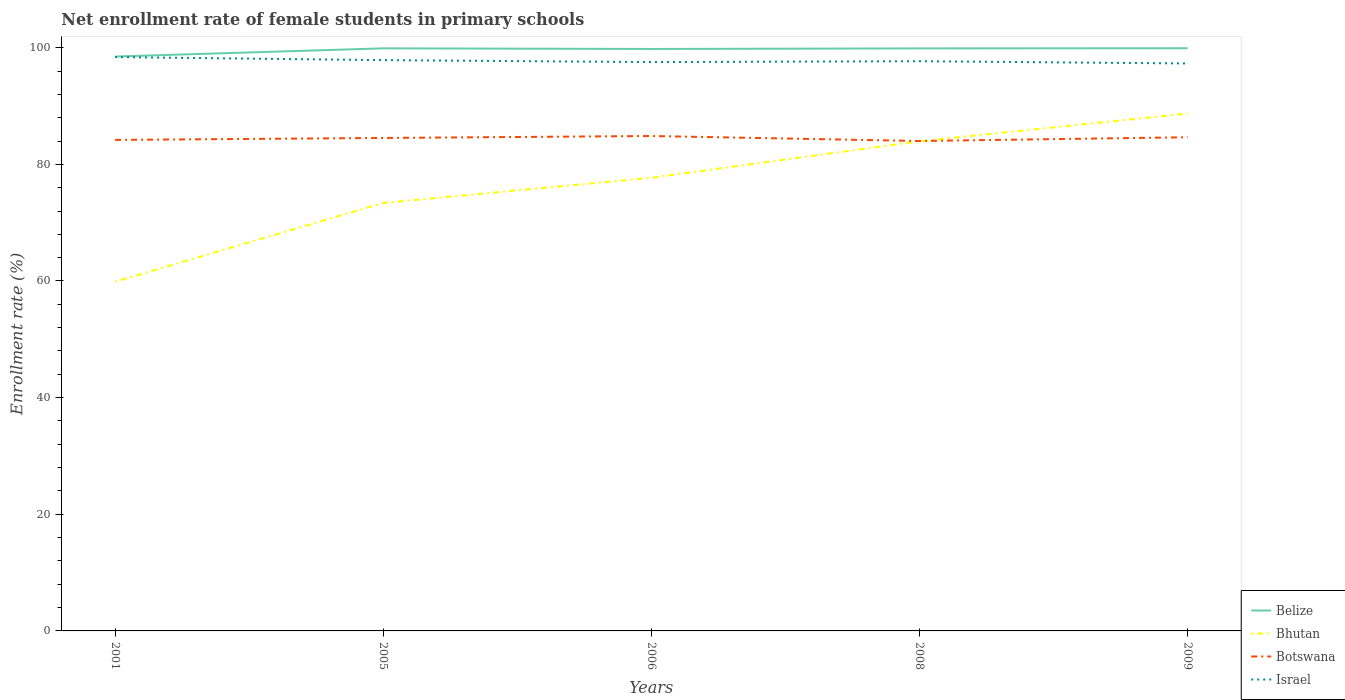How many different coloured lines are there?
Provide a short and direct response. 4. Is the number of lines equal to the number of legend labels?
Offer a terse response. Yes. Across all years, what is the maximum net enrollment rate of female students in primary schools in Israel?
Your answer should be very brief. 97.3. What is the total net enrollment rate of female students in primary schools in Bhutan in the graph?
Provide a succinct answer. -10.58. What is the difference between the highest and the second highest net enrollment rate of female students in primary schools in Botswana?
Provide a short and direct response. 0.86. What is the difference between the highest and the lowest net enrollment rate of female students in primary schools in Israel?
Provide a succinct answer. 2. Is the net enrollment rate of female students in primary schools in Israel strictly greater than the net enrollment rate of female students in primary schools in Botswana over the years?
Provide a short and direct response. No. Are the values on the major ticks of Y-axis written in scientific E-notation?
Your answer should be very brief. No. Does the graph contain grids?
Offer a terse response. No. Where does the legend appear in the graph?
Offer a very short reply. Bottom right. How many legend labels are there?
Your response must be concise. 4. How are the legend labels stacked?
Give a very brief answer. Vertical. What is the title of the graph?
Ensure brevity in your answer.  Net enrollment rate of female students in primary schools. Does "Kazakhstan" appear as one of the legend labels in the graph?
Provide a succinct answer. No. What is the label or title of the X-axis?
Your response must be concise. Years. What is the label or title of the Y-axis?
Your answer should be compact. Enrollment rate (%). What is the Enrollment rate (%) of Belize in 2001?
Your answer should be very brief. 98.49. What is the Enrollment rate (%) in Bhutan in 2001?
Ensure brevity in your answer.  59.88. What is the Enrollment rate (%) in Botswana in 2001?
Provide a succinct answer. 84.19. What is the Enrollment rate (%) in Israel in 2001?
Ensure brevity in your answer.  98.39. What is the Enrollment rate (%) in Belize in 2005?
Keep it short and to the point. 99.89. What is the Enrollment rate (%) in Bhutan in 2005?
Offer a terse response. 73.38. What is the Enrollment rate (%) of Botswana in 2005?
Ensure brevity in your answer.  84.52. What is the Enrollment rate (%) in Israel in 2005?
Ensure brevity in your answer.  97.87. What is the Enrollment rate (%) of Belize in 2006?
Offer a terse response. 99.78. What is the Enrollment rate (%) in Bhutan in 2006?
Your answer should be very brief. 77.7. What is the Enrollment rate (%) in Botswana in 2006?
Make the answer very short. 84.86. What is the Enrollment rate (%) of Israel in 2006?
Ensure brevity in your answer.  97.53. What is the Enrollment rate (%) in Belize in 2008?
Offer a very short reply. 99.88. What is the Enrollment rate (%) of Bhutan in 2008?
Keep it short and to the point. 83.95. What is the Enrollment rate (%) of Botswana in 2008?
Offer a very short reply. 84. What is the Enrollment rate (%) in Israel in 2008?
Your answer should be compact. 97.68. What is the Enrollment rate (%) in Belize in 2009?
Provide a succinct answer. 99.91. What is the Enrollment rate (%) of Bhutan in 2009?
Ensure brevity in your answer.  88.72. What is the Enrollment rate (%) of Botswana in 2009?
Your answer should be compact. 84.65. What is the Enrollment rate (%) in Israel in 2009?
Offer a terse response. 97.3. Across all years, what is the maximum Enrollment rate (%) in Belize?
Offer a very short reply. 99.91. Across all years, what is the maximum Enrollment rate (%) of Bhutan?
Ensure brevity in your answer.  88.72. Across all years, what is the maximum Enrollment rate (%) in Botswana?
Give a very brief answer. 84.86. Across all years, what is the maximum Enrollment rate (%) of Israel?
Your answer should be compact. 98.39. Across all years, what is the minimum Enrollment rate (%) of Belize?
Offer a very short reply. 98.49. Across all years, what is the minimum Enrollment rate (%) in Bhutan?
Your answer should be very brief. 59.88. Across all years, what is the minimum Enrollment rate (%) in Botswana?
Keep it short and to the point. 84. Across all years, what is the minimum Enrollment rate (%) of Israel?
Offer a terse response. 97.3. What is the total Enrollment rate (%) in Belize in the graph?
Ensure brevity in your answer.  497.95. What is the total Enrollment rate (%) in Bhutan in the graph?
Give a very brief answer. 383.63. What is the total Enrollment rate (%) of Botswana in the graph?
Offer a very short reply. 422.23. What is the total Enrollment rate (%) of Israel in the graph?
Your answer should be compact. 488.78. What is the difference between the Enrollment rate (%) in Belize in 2001 and that in 2005?
Provide a succinct answer. -1.4. What is the difference between the Enrollment rate (%) of Bhutan in 2001 and that in 2005?
Your answer should be compact. -13.5. What is the difference between the Enrollment rate (%) of Botswana in 2001 and that in 2005?
Offer a very short reply. -0.33. What is the difference between the Enrollment rate (%) of Israel in 2001 and that in 2005?
Provide a succinct answer. 0.52. What is the difference between the Enrollment rate (%) in Belize in 2001 and that in 2006?
Provide a short and direct response. -1.3. What is the difference between the Enrollment rate (%) in Bhutan in 2001 and that in 2006?
Make the answer very short. -17.82. What is the difference between the Enrollment rate (%) in Botswana in 2001 and that in 2006?
Provide a short and direct response. -0.67. What is the difference between the Enrollment rate (%) in Israel in 2001 and that in 2006?
Ensure brevity in your answer.  0.86. What is the difference between the Enrollment rate (%) of Belize in 2001 and that in 2008?
Your answer should be very brief. -1.4. What is the difference between the Enrollment rate (%) in Bhutan in 2001 and that in 2008?
Your answer should be very brief. -24.08. What is the difference between the Enrollment rate (%) of Botswana in 2001 and that in 2008?
Make the answer very short. 0.19. What is the difference between the Enrollment rate (%) of Israel in 2001 and that in 2008?
Your response must be concise. 0.7. What is the difference between the Enrollment rate (%) of Belize in 2001 and that in 2009?
Offer a terse response. -1.42. What is the difference between the Enrollment rate (%) in Bhutan in 2001 and that in 2009?
Your answer should be compact. -28.84. What is the difference between the Enrollment rate (%) of Botswana in 2001 and that in 2009?
Keep it short and to the point. -0.45. What is the difference between the Enrollment rate (%) in Israel in 2001 and that in 2009?
Ensure brevity in your answer.  1.09. What is the difference between the Enrollment rate (%) of Belize in 2005 and that in 2006?
Your answer should be compact. 0.11. What is the difference between the Enrollment rate (%) in Bhutan in 2005 and that in 2006?
Make the answer very short. -4.32. What is the difference between the Enrollment rate (%) of Botswana in 2005 and that in 2006?
Make the answer very short. -0.33. What is the difference between the Enrollment rate (%) of Israel in 2005 and that in 2006?
Provide a succinct answer. 0.34. What is the difference between the Enrollment rate (%) of Belize in 2005 and that in 2008?
Your answer should be compact. 0.01. What is the difference between the Enrollment rate (%) in Bhutan in 2005 and that in 2008?
Keep it short and to the point. -10.58. What is the difference between the Enrollment rate (%) of Botswana in 2005 and that in 2008?
Your response must be concise. 0.52. What is the difference between the Enrollment rate (%) in Israel in 2005 and that in 2008?
Give a very brief answer. 0.19. What is the difference between the Enrollment rate (%) in Belize in 2005 and that in 2009?
Your answer should be very brief. -0.02. What is the difference between the Enrollment rate (%) of Bhutan in 2005 and that in 2009?
Give a very brief answer. -15.34. What is the difference between the Enrollment rate (%) in Botswana in 2005 and that in 2009?
Make the answer very short. -0.12. What is the difference between the Enrollment rate (%) in Israel in 2005 and that in 2009?
Offer a very short reply. 0.57. What is the difference between the Enrollment rate (%) in Belize in 2006 and that in 2008?
Your answer should be very brief. -0.1. What is the difference between the Enrollment rate (%) of Bhutan in 2006 and that in 2008?
Your answer should be compact. -6.25. What is the difference between the Enrollment rate (%) in Botswana in 2006 and that in 2008?
Your answer should be compact. 0.86. What is the difference between the Enrollment rate (%) in Israel in 2006 and that in 2008?
Your answer should be very brief. -0.15. What is the difference between the Enrollment rate (%) in Belize in 2006 and that in 2009?
Keep it short and to the point. -0.12. What is the difference between the Enrollment rate (%) in Bhutan in 2006 and that in 2009?
Offer a terse response. -11.02. What is the difference between the Enrollment rate (%) in Botswana in 2006 and that in 2009?
Make the answer very short. 0.21. What is the difference between the Enrollment rate (%) in Israel in 2006 and that in 2009?
Your answer should be very brief. 0.23. What is the difference between the Enrollment rate (%) in Belize in 2008 and that in 2009?
Offer a terse response. -0.02. What is the difference between the Enrollment rate (%) of Bhutan in 2008 and that in 2009?
Provide a short and direct response. -4.76. What is the difference between the Enrollment rate (%) of Botswana in 2008 and that in 2009?
Offer a very short reply. -0.64. What is the difference between the Enrollment rate (%) of Israel in 2008 and that in 2009?
Your response must be concise. 0.38. What is the difference between the Enrollment rate (%) in Belize in 2001 and the Enrollment rate (%) in Bhutan in 2005?
Your answer should be very brief. 25.11. What is the difference between the Enrollment rate (%) of Belize in 2001 and the Enrollment rate (%) of Botswana in 2005?
Give a very brief answer. 13.96. What is the difference between the Enrollment rate (%) of Belize in 2001 and the Enrollment rate (%) of Israel in 2005?
Your response must be concise. 0.62. What is the difference between the Enrollment rate (%) in Bhutan in 2001 and the Enrollment rate (%) in Botswana in 2005?
Keep it short and to the point. -24.65. What is the difference between the Enrollment rate (%) in Bhutan in 2001 and the Enrollment rate (%) in Israel in 2005?
Offer a terse response. -37.99. What is the difference between the Enrollment rate (%) of Botswana in 2001 and the Enrollment rate (%) of Israel in 2005?
Offer a very short reply. -13.68. What is the difference between the Enrollment rate (%) of Belize in 2001 and the Enrollment rate (%) of Bhutan in 2006?
Keep it short and to the point. 20.78. What is the difference between the Enrollment rate (%) of Belize in 2001 and the Enrollment rate (%) of Botswana in 2006?
Provide a short and direct response. 13.63. What is the difference between the Enrollment rate (%) of Belize in 2001 and the Enrollment rate (%) of Israel in 2006?
Make the answer very short. 0.95. What is the difference between the Enrollment rate (%) in Bhutan in 2001 and the Enrollment rate (%) in Botswana in 2006?
Provide a short and direct response. -24.98. What is the difference between the Enrollment rate (%) of Bhutan in 2001 and the Enrollment rate (%) of Israel in 2006?
Ensure brevity in your answer.  -37.65. What is the difference between the Enrollment rate (%) in Botswana in 2001 and the Enrollment rate (%) in Israel in 2006?
Your answer should be compact. -13.34. What is the difference between the Enrollment rate (%) in Belize in 2001 and the Enrollment rate (%) in Bhutan in 2008?
Your answer should be compact. 14.53. What is the difference between the Enrollment rate (%) in Belize in 2001 and the Enrollment rate (%) in Botswana in 2008?
Offer a very short reply. 14.48. What is the difference between the Enrollment rate (%) in Belize in 2001 and the Enrollment rate (%) in Israel in 2008?
Ensure brevity in your answer.  0.8. What is the difference between the Enrollment rate (%) of Bhutan in 2001 and the Enrollment rate (%) of Botswana in 2008?
Ensure brevity in your answer.  -24.13. What is the difference between the Enrollment rate (%) of Bhutan in 2001 and the Enrollment rate (%) of Israel in 2008?
Keep it short and to the point. -37.81. What is the difference between the Enrollment rate (%) in Botswana in 2001 and the Enrollment rate (%) in Israel in 2008?
Give a very brief answer. -13.49. What is the difference between the Enrollment rate (%) in Belize in 2001 and the Enrollment rate (%) in Bhutan in 2009?
Your response must be concise. 9.77. What is the difference between the Enrollment rate (%) in Belize in 2001 and the Enrollment rate (%) in Botswana in 2009?
Your answer should be compact. 13.84. What is the difference between the Enrollment rate (%) in Belize in 2001 and the Enrollment rate (%) in Israel in 2009?
Give a very brief answer. 1.19. What is the difference between the Enrollment rate (%) of Bhutan in 2001 and the Enrollment rate (%) of Botswana in 2009?
Keep it short and to the point. -24.77. What is the difference between the Enrollment rate (%) in Bhutan in 2001 and the Enrollment rate (%) in Israel in 2009?
Give a very brief answer. -37.42. What is the difference between the Enrollment rate (%) in Botswana in 2001 and the Enrollment rate (%) in Israel in 2009?
Give a very brief answer. -13.11. What is the difference between the Enrollment rate (%) in Belize in 2005 and the Enrollment rate (%) in Bhutan in 2006?
Offer a very short reply. 22.19. What is the difference between the Enrollment rate (%) in Belize in 2005 and the Enrollment rate (%) in Botswana in 2006?
Provide a succinct answer. 15.03. What is the difference between the Enrollment rate (%) in Belize in 2005 and the Enrollment rate (%) in Israel in 2006?
Keep it short and to the point. 2.36. What is the difference between the Enrollment rate (%) in Bhutan in 2005 and the Enrollment rate (%) in Botswana in 2006?
Give a very brief answer. -11.48. What is the difference between the Enrollment rate (%) of Bhutan in 2005 and the Enrollment rate (%) of Israel in 2006?
Keep it short and to the point. -24.15. What is the difference between the Enrollment rate (%) in Botswana in 2005 and the Enrollment rate (%) in Israel in 2006?
Make the answer very short. -13.01. What is the difference between the Enrollment rate (%) of Belize in 2005 and the Enrollment rate (%) of Bhutan in 2008?
Keep it short and to the point. 15.94. What is the difference between the Enrollment rate (%) in Belize in 2005 and the Enrollment rate (%) in Botswana in 2008?
Your response must be concise. 15.89. What is the difference between the Enrollment rate (%) in Belize in 2005 and the Enrollment rate (%) in Israel in 2008?
Your response must be concise. 2.21. What is the difference between the Enrollment rate (%) in Bhutan in 2005 and the Enrollment rate (%) in Botswana in 2008?
Offer a very short reply. -10.63. What is the difference between the Enrollment rate (%) of Bhutan in 2005 and the Enrollment rate (%) of Israel in 2008?
Make the answer very short. -24.31. What is the difference between the Enrollment rate (%) of Botswana in 2005 and the Enrollment rate (%) of Israel in 2008?
Offer a very short reply. -13.16. What is the difference between the Enrollment rate (%) in Belize in 2005 and the Enrollment rate (%) in Bhutan in 2009?
Your response must be concise. 11.17. What is the difference between the Enrollment rate (%) in Belize in 2005 and the Enrollment rate (%) in Botswana in 2009?
Provide a short and direct response. 15.24. What is the difference between the Enrollment rate (%) in Belize in 2005 and the Enrollment rate (%) in Israel in 2009?
Provide a succinct answer. 2.59. What is the difference between the Enrollment rate (%) in Bhutan in 2005 and the Enrollment rate (%) in Botswana in 2009?
Offer a very short reply. -11.27. What is the difference between the Enrollment rate (%) of Bhutan in 2005 and the Enrollment rate (%) of Israel in 2009?
Make the answer very short. -23.92. What is the difference between the Enrollment rate (%) in Botswana in 2005 and the Enrollment rate (%) in Israel in 2009?
Your response must be concise. -12.78. What is the difference between the Enrollment rate (%) in Belize in 2006 and the Enrollment rate (%) in Bhutan in 2008?
Your response must be concise. 15.83. What is the difference between the Enrollment rate (%) of Belize in 2006 and the Enrollment rate (%) of Botswana in 2008?
Ensure brevity in your answer.  15.78. What is the difference between the Enrollment rate (%) in Belize in 2006 and the Enrollment rate (%) in Israel in 2008?
Your answer should be very brief. 2.1. What is the difference between the Enrollment rate (%) in Bhutan in 2006 and the Enrollment rate (%) in Botswana in 2008?
Offer a very short reply. -6.3. What is the difference between the Enrollment rate (%) in Bhutan in 2006 and the Enrollment rate (%) in Israel in 2008?
Make the answer very short. -19.98. What is the difference between the Enrollment rate (%) in Botswana in 2006 and the Enrollment rate (%) in Israel in 2008?
Provide a short and direct response. -12.83. What is the difference between the Enrollment rate (%) in Belize in 2006 and the Enrollment rate (%) in Bhutan in 2009?
Your response must be concise. 11.06. What is the difference between the Enrollment rate (%) in Belize in 2006 and the Enrollment rate (%) in Botswana in 2009?
Provide a succinct answer. 15.14. What is the difference between the Enrollment rate (%) of Belize in 2006 and the Enrollment rate (%) of Israel in 2009?
Provide a short and direct response. 2.48. What is the difference between the Enrollment rate (%) in Bhutan in 2006 and the Enrollment rate (%) in Botswana in 2009?
Provide a succinct answer. -6.95. What is the difference between the Enrollment rate (%) of Bhutan in 2006 and the Enrollment rate (%) of Israel in 2009?
Your response must be concise. -19.6. What is the difference between the Enrollment rate (%) of Botswana in 2006 and the Enrollment rate (%) of Israel in 2009?
Keep it short and to the point. -12.44. What is the difference between the Enrollment rate (%) of Belize in 2008 and the Enrollment rate (%) of Bhutan in 2009?
Offer a very short reply. 11.16. What is the difference between the Enrollment rate (%) of Belize in 2008 and the Enrollment rate (%) of Botswana in 2009?
Your answer should be compact. 15.24. What is the difference between the Enrollment rate (%) in Belize in 2008 and the Enrollment rate (%) in Israel in 2009?
Provide a short and direct response. 2.58. What is the difference between the Enrollment rate (%) in Bhutan in 2008 and the Enrollment rate (%) in Botswana in 2009?
Make the answer very short. -0.69. What is the difference between the Enrollment rate (%) in Bhutan in 2008 and the Enrollment rate (%) in Israel in 2009?
Keep it short and to the point. -13.35. What is the difference between the Enrollment rate (%) in Botswana in 2008 and the Enrollment rate (%) in Israel in 2009?
Provide a succinct answer. -13.3. What is the average Enrollment rate (%) in Belize per year?
Your answer should be very brief. 99.59. What is the average Enrollment rate (%) in Bhutan per year?
Keep it short and to the point. 76.73. What is the average Enrollment rate (%) in Botswana per year?
Offer a terse response. 84.44. What is the average Enrollment rate (%) in Israel per year?
Provide a short and direct response. 97.76. In the year 2001, what is the difference between the Enrollment rate (%) in Belize and Enrollment rate (%) in Bhutan?
Keep it short and to the point. 38.61. In the year 2001, what is the difference between the Enrollment rate (%) in Belize and Enrollment rate (%) in Botswana?
Give a very brief answer. 14.29. In the year 2001, what is the difference between the Enrollment rate (%) of Belize and Enrollment rate (%) of Israel?
Make the answer very short. 0.1. In the year 2001, what is the difference between the Enrollment rate (%) in Bhutan and Enrollment rate (%) in Botswana?
Ensure brevity in your answer.  -24.32. In the year 2001, what is the difference between the Enrollment rate (%) of Bhutan and Enrollment rate (%) of Israel?
Make the answer very short. -38.51. In the year 2001, what is the difference between the Enrollment rate (%) in Botswana and Enrollment rate (%) in Israel?
Offer a very short reply. -14.2. In the year 2005, what is the difference between the Enrollment rate (%) of Belize and Enrollment rate (%) of Bhutan?
Your answer should be compact. 26.51. In the year 2005, what is the difference between the Enrollment rate (%) in Belize and Enrollment rate (%) in Botswana?
Make the answer very short. 15.37. In the year 2005, what is the difference between the Enrollment rate (%) of Belize and Enrollment rate (%) of Israel?
Provide a succinct answer. 2.02. In the year 2005, what is the difference between the Enrollment rate (%) in Bhutan and Enrollment rate (%) in Botswana?
Offer a very short reply. -11.15. In the year 2005, what is the difference between the Enrollment rate (%) of Bhutan and Enrollment rate (%) of Israel?
Offer a very short reply. -24.49. In the year 2005, what is the difference between the Enrollment rate (%) of Botswana and Enrollment rate (%) of Israel?
Provide a succinct answer. -13.35. In the year 2006, what is the difference between the Enrollment rate (%) of Belize and Enrollment rate (%) of Bhutan?
Your answer should be very brief. 22.08. In the year 2006, what is the difference between the Enrollment rate (%) of Belize and Enrollment rate (%) of Botswana?
Your answer should be very brief. 14.92. In the year 2006, what is the difference between the Enrollment rate (%) of Belize and Enrollment rate (%) of Israel?
Provide a short and direct response. 2.25. In the year 2006, what is the difference between the Enrollment rate (%) of Bhutan and Enrollment rate (%) of Botswana?
Give a very brief answer. -7.16. In the year 2006, what is the difference between the Enrollment rate (%) in Bhutan and Enrollment rate (%) in Israel?
Give a very brief answer. -19.83. In the year 2006, what is the difference between the Enrollment rate (%) of Botswana and Enrollment rate (%) of Israel?
Your answer should be compact. -12.67. In the year 2008, what is the difference between the Enrollment rate (%) in Belize and Enrollment rate (%) in Bhutan?
Your response must be concise. 15.93. In the year 2008, what is the difference between the Enrollment rate (%) of Belize and Enrollment rate (%) of Botswana?
Keep it short and to the point. 15.88. In the year 2008, what is the difference between the Enrollment rate (%) of Belize and Enrollment rate (%) of Israel?
Provide a succinct answer. 2.2. In the year 2008, what is the difference between the Enrollment rate (%) in Bhutan and Enrollment rate (%) in Botswana?
Your answer should be compact. -0.05. In the year 2008, what is the difference between the Enrollment rate (%) in Bhutan and Enrollment rate (%) in Israel?
Make the answer very short. -13.73. In the year 2008, what is the difference between the Enrollment rate (%) in Botswana and Enrollment rate (%) in Israel?
Your answer should be compact. -13.68. In the year 2009, what is the difference between the Enrollment rate (%) of Belize and Enrollment rate (%) of Bhutan?
Ensure brevity in your answer.  11.19. In the year 2009, what is the difference between the Enrollment rate (%) in Belize and Enrollment rate (%) in Botswana?
Your answer should be very brief. 15.26. In the year 2009, what is the difference between the Enrollment rate (%) of Belize and Enrollment rate (%) of Israel?
Your response must be concise. 2.61. In the year 2009, what is the difference between the Enrollment rate (%) in Bhutan and Enrollment rate (%) in Botswana?
Your answer should be very brief. 4.07. In the year 2009, what is the difference between the Enrollment rate (%) in Bhutan and Enrollment rate (%) in Israel?
Your answer should be very brief. -8.58. In the year 2009, what is the difference between the Enrollment rate (%) in Botswana and Enrollment rate (%) in Israel?
Give a very brief answer. -12.65. What is the ratio of the Enrollment rate (%) of Belize in 2001 to that in 2005?
Keep it short and to the point. 0.99. What is the ratio of the Enrollment rate (%) in Bhutan in 2001 to that in 2005?
Give a very brief answer. 0.82. What is the ratio of the Enrollment rate (%) of Israel in 2001 to that in 2005?
Offer a very short reply. 1.01. What is the ratio of the Enrollment rate (%) of Bhutan in 2001 to that in 2006?
Your response must be concise. 0.77. What is the ratio of the Enrollment rate (%) of Israel in 2001 to that in 2006?
Your answer should be compact. 1.01. What is the ratio of the Enrollment rate (%) of Belize in 2001 to that in 2008?
Keep it short and to the point. 0.99. What is the ratio of the Enrollment rate (%) in Bhutan in 2001 to that in 2008?
Provide a succinct answer. 0.71. What is the ratio of the Enrollment rate (%) of Botswana in 2001 to that in 2008?
Your answer should be very brief. 1. What is the ratio of the Enrollment rate (%) in Israel in 2001 to that in 2008?
Your answer should be compact. 1.01. What is the ratio of the Enrollment rate (%) in Belize in 2001 to that in 2009?
Provide a succinct answer. 0.99. What is the ratio of the Enrollment rate (%) of Bhutan in 2001 to that in 2009?
Your response must be concise. 0.67. What is the ratio of the Enrollment rate (%) in Botswana in 2001 to that in 2009?
Provide a succinct answer. 0.99. What is the ratio of the Enrollment rate (%) in Israel in 2001 to that in 2009?
Your answer should be compact. 1.01. What is the ratio of the Enrollment rate (%) in Belize in 2005 to that in 2006?
Provide a succinct answer. 1. What is the ratio of the Enrollment rate (%) of Bhutan in 2005 to that in 2006?
Keep it short and to the point. 0.94. What is the ratio of the Enrollment rate (%) of Israel in 2005 to that in 2006?
Provide a succinct answer. 1. What is the ratio of the Enrollment rate (%) of Belize in 2005 to that in 2008?
Your answer should be compact. 1. What is the ratio of the Enrollment rate (%) in Bhutan in 2005 to that in 2008?
Your response must be concise. 0.87. What is the ratio of the Enrollment rate (%) in Botswana in 2005 to that in 2008?
Your answer should be compact. 1.01. What is the ratio of the Enrollment rate (%) of Belize in 2005 to that in 2009?
Keep it short and to the point. 1. What is the ratio of the Enrollment rate (%) of Bhutan in 2005 to that in 2009?
Ensure brevity in your answer.  0.83. What is the ratio of the Enrollment rate (%) of Botswana in 2005 to that in 2009?
Provide a short and direct response. 1. What is the ratio of the Enrollment rate (%) of Israel in 2005 to that in 2009?
Ensure brevity in your answer.  1.01. What is the ratio of the Enrollment rate (%) of Belize in 2006 to that in 2008?
Provide a short and direct response. 1. What is the ratio of the Enrollment rate (%) of Bhutan in 2006 to that in 2008?
Give a very brief answer. 0.93. What is the ratio of the Enrollment rate (%) in Botswana in 2006 to that in 2008?
Keep it short and to the point. 1.01. What is the ratio of the Enrollment rate (%) in Belize in 2006 to that in 2009?
Your response must be concise. 1. What is the ratio of the Enrollment rate (%) in Bhutan in 2006 to that in 2009?
Ensure brevity in your answer.  0.88. What is the ratio of the Enrollment rate (%) in Botswana in 2006 to that in 2009?
Offer a very short reply. 1. What is the ratio of the Enrollment rate (%) of Belize in 2008 to that in 2009?
Offer a very short reply. 1. What is the ratio of the Enrollment rate (%) of Bhutan in 2008 to that in 2009?
Ensure brevity in your answer.  0.95. What is the difference between the highest and the second highest Enrollment rate (%) of Belize?
Offer a very short reply. 0.02. What is the difference between the highest and the second highest Enrollment rate (%) of Bhutan?
Your answer should be compact. 4.76. What is the difference between the highest and the second highest Enrollment rate (%) in Botswana?
Your answer should be very brief. 0.21. What is the difference between the highest and the second highest Enrollment rate (%) of Israel?
Provide a short and direct response. 0.52. What is the difference between the highest and the lowest Enrollment rate (%) of Belize?
Your answer should be very brief. 1.42. What is the difference between the highest and the lowest Enrollment rate (%) of Bhutan?
Make the answer very short. 28.84. What is the difference between the highest and the lowest Enrollment rate (%) in Botswana?
Your answer should be very brief. 0.86. What is the difference between the highest and the lowest Enrollment rate (%) of Israel?
Provide a succinct answer. 1.09. 